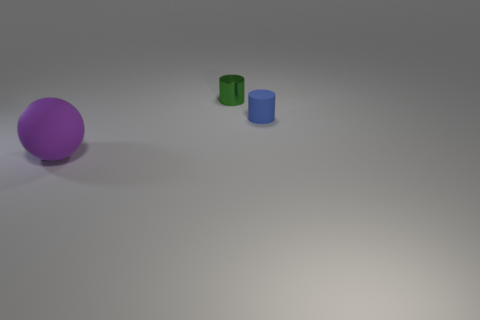Are there any other things that have the same shape as the large object?
Offer a very short reply. No. Are there any other things that are the same material as the small green thing?
Provide a succinct answer. No. Are there fewer cylinders than things?
Your answer should be compact. Yes. What material is the thing in front of the rubber object right of the big purple matte sphere?
Make the answer very short. Rubber. Is the shiny cylinder the same size as the blue matte object?
Keep it short and to the point. Yes. What number of objects are either red blocks or big matte things?
Offer a terse response. 1. What size is the object that is behind the purple object and in front of the tiny green shiny object?
Your answer should be very brief. Small. Are there fewer small blue matte objects that are left of the large purple ball than metal objects?
Provide a short and direct response. Yes. What shape is the small blue object that is made of the same material as the sphere?
Give a very brief answer. Cylinder. Does the thing in front of the small matte object have the same shape as the rubber thing on the right side of the big purple rubber ball?
Give a very brief answer. No. 